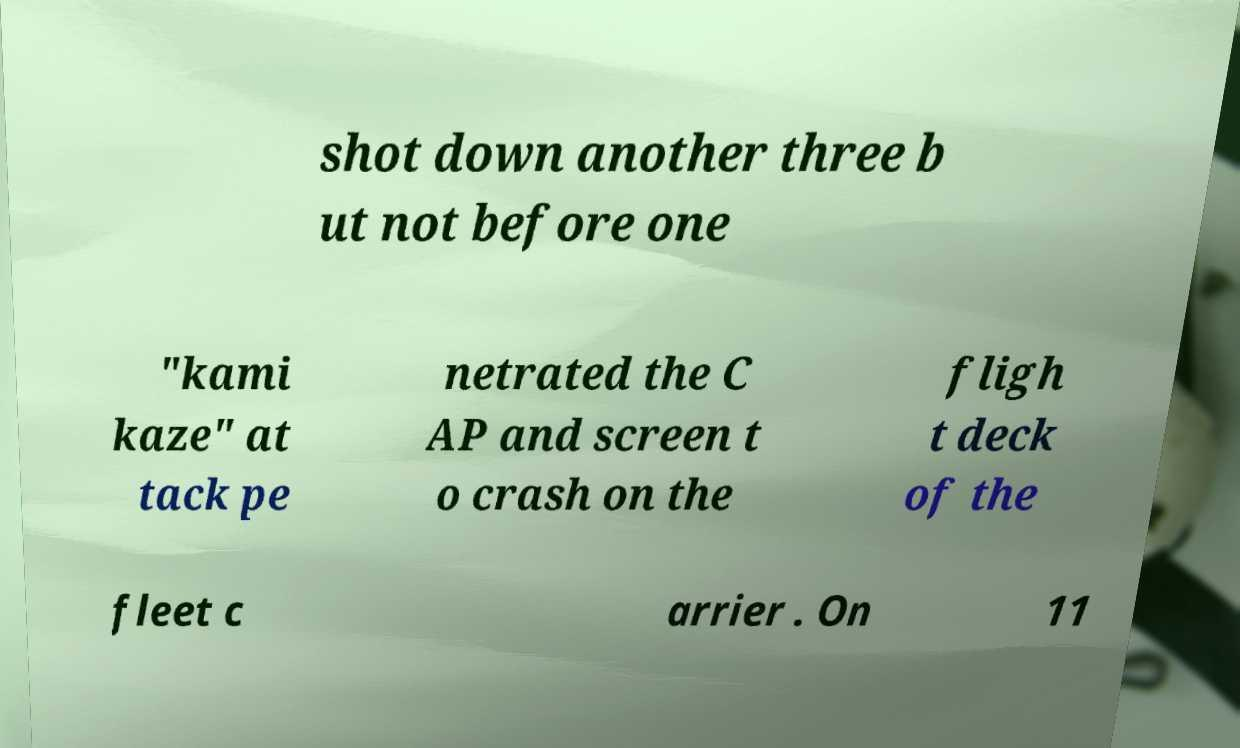Please identify and transcribe the text found in this image. shot down another three b ut not before one "kami kaze" at tack pe netrated the C AP and screen t o crash on the fligh t deck of the fleet c arrier . On 11 